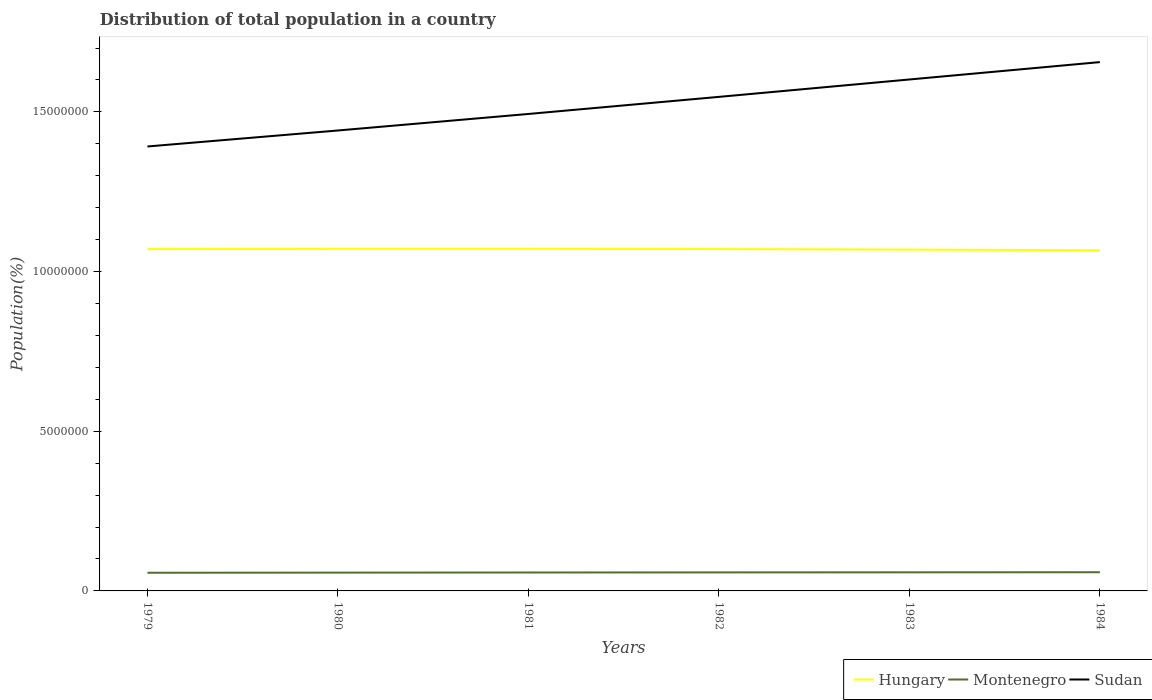Does the line corresponding to Montenegro intersect with the line corresponding to Sudan?
Offer a very short reply. No. Across all years, what is the maximum population of in Sudan?
Your response must be concise. 1.39e+07. In which year was the population of in Montenegro maximum?
Your answer should be very brief. 1979. What is the total population of in Sudan in the graph?
Offer a very short reply. -5.01e+05. What is the difference between the highest and the second highest population of in Hungary?
Your answer should be compact. 4.38e+04. Is the population of in Hungary strictly greater than the population of in Montenegro over the years?
Give a very brief answer. No. How many years are there in the graph?
Your answer should be compact. 6. What is the difference between two consecutive major ticks on the Y-axis?
Provide a short and direct response. 5.00e+06. Are the values on the major ticks of Y-axis written in scientific E-notation?
Provide a succinct answer. No. Where does the legend appear in the graph?
Offer a very short reply. Bottom right. How many legend labels are there?
Your answer should be compact. 3. What is the title of the graph?
Your response must be concise. Distribution of total population in a country. What is the label or title of the X-axis?
Your answer should be very brief. Years. What is the label or title of the Y-axis?
Give a very brief answer. Population(%). What is the Population(%) in Hungary in 1979?
Your answer should be very brief. 1.07e+07. What is the Population(%) of Montenegro in 1979?
Make the answer very short. 5.69e+05. What is the Population(%) of Sudan in 1979?
Your answer should be compact. 1.39e+07. What is the Population(%) in Hungary in 1980?
Offer a very short reply. 1.07e+07. What is the Population(%) of Montenegro in 1980?
Your answer should be compact. 5.73e+05. What is the Population(%) of Sudan in 1980?
Your response must be concise. 1.44e+07. What is the Population(%) of Hungary in 1981?
Give a very brief answer. 1.07e+07. What is the Population(%) of Montenegro in 1981?
Offer a terse response. 5.77e+05. What is the Population(%) in Sudan in 1981?
Your answer should be compact. 1.49e+07. What is the Population(%) in Hungary in 1982?
Provide a short and direct response. 1.07e+07. What is the Population(%) in Montenegro in 1982?
Ensure brevity in your answer.  5.80e+05. What is the Population(%) in Sudan in 1982?
Keep it short and to the point. 1.55e+07. What is the Population(%) of Hungary in 1983?
Make the answer very short. 1.07e+07. What is the Population(%) in Montenegro in 1983?
Give a very brief answer. 5.82e+05. What is the Population(%) of Sudan in 1983?
Provide a short and direct response. 1.60e+07. What is the Population(%) in Hungary in 1984?
Provide a succinct answer. 1.07e+07. What is the Population(%) in Montenegro in 1984?
Offer a terse response. 5.85e+05. What is the Population(%) of Sudan in 1984?
Provide a succinct answer. 1.66e+07. Across all years, what is the maximum Population(%) in Hungary?
Your response must be concise. 1.07e+07. Across all years, what is the maximum Population(%) in Montenegro?
Your answer should be compact. 5.85e+05. Across all years, what is the maximum Population(%) in Sudan?
Give a very brief answer. 1.66e+07. Across all years, what is the minimum Population(%) of Hungary?
Keep it short and to the point. 1.07e+07. Across all years, what is the minimum Population(%) in Montenegro?
Provide a short and direct response. 5.69e+05. Across all years, what is the minimum Population(%) of Sudan?
Ensure brevity in your answer.  1.39e+07. What is the total Population(%) of Hungary in the graph?
Your response must be concise. 6.42e+07. What is the total Population(%) in Montenegro in the graph?
Offer a very short reply. 3.47e+06. What is the total Population(%) of Sudan in the graph?
Give a very brief answer. 9.13e+07. What is the difference between the Population(%) in Hungary in 1979 and that in 1980?
Offer a very short reply. -6970. What is the difference between the Population(%) in Montenegro in 1979 and that in 1980?
Your answer should be compact. -4204. What is the difference between the Population(%) in Sudan in 1979 and that in 1980?
Your response must be concise. -5.01e+05. What is the difference between the Population(%) of Hungary in 1979 and that in 1981?
Your answer should be compact. -7696. What is the difference between the Population(%) in Montenegro in 1979 and that in 1981?
Ensure brevity in your answer.  -7712. What is the difference between the Population(%) of Sudan in 1979 and that in 1981?
Your response must be concise. -1.02e+06. What is the difference between the Population(%) in Hungary in 1979 and that in 1982?
Give a very brief answer. -1383. What is the difference between the Population(%) in Montenegro in 1979 and that in 1982?
Provide a succinct answer. -1.06e+04. What is the difference between the Population(%) of Sudan in 1979 and that in 1982?
Your response must be concise. -1.55e+06. What is the difference between the Population(%) of Hungary in 1979 and that in 1983?
Your answer should be very brief. 1.47e+04. What is the difference between the Population(%) in Montenegro in 1979 and that in 1983?
Ensure brevity in your answer.  -1.33e+04. What is the difference between the Population(%) in Sudan in 1979 and that in 1983?
Keep it short and to the point. -2.10e+06. What is the difference between the Population(%) of Hungary in 1979 and that in 1984?
Keep it short and to the point. 3.61e+04. What is the difference between the Population(%) of Montenegro in 1979 and that in 1984?
Provide a short and direct response. -1.61e+04. What is the difference between the Population(%) of Sudan in 1979 and that in 1984?
Keep it short and to the point. -2.64e+06. What is the difference between the Population(%) of Hungary in 1980 and that in 1981?
Offer a terse response. -726. What is the difference between the Population(%) in Montenegro in 1980 and that in 1981?
Provide a succinct answer. -3508. What is the difference between the Population(%) in Sudan in 1980 and that in 1981?
Ensure brevity in your answer.  -5.17e+05. What is the difference between the Population(%) in Hungary in 1980 and that in 1982?
Your answer should be very brief. 5587. What is the difference between the Population(%) in Montenegro in 1980 and that in 1982?
Offer a very short reply. -6411. What is the difference between the Population(%) in Sudan in 1980 and that in 1982?
Your answer should be compact. -1.05e+06. What is the difference between the Population(%) in Hungary in 1980 and that in 1983?
Your response must be concise. 2.17e+04. What is the difference between the Population(%) of Montenegro in 1980 and that in 1983?
Provide a succinct answer. -9047. What is the difference between the Population(%) in Sudan in 1980 and that in 1983?
Your answer should be very brief. -1.60e+06. What is the difference between the Population(%) in Hungary in 1980 and that in 1984?
Your answer should be compact. 4.30e+04. What is the difference between the Population(%) in Montenegro in 1980 and that in 1984?
Keep it short and to the point. -1.19e+04. What is the difference between the Population(%) of Sudan in 1980 and that in 1984?
Your response must be concise. -2.14e+06. What is the difference between the Population(%) in Hungary in 1981 and that in 1982?
Offer a very short reply. 6313. What is the difference between the Population(%) in Montenegro in 1981 and that in 1982?
Keep it short and to the point. -2903. What is the difference between the Population(%) of Sudan in 1981 and that in 1982?
Provide a succinct answer. -5.35e+05. What is the difference between the Population(%) in Hungary in 1981 and that in 1983?
Make the answer very short. 2.24e+04. What is the difference between the Population(%) of Montenegro in 1981 and that in 1983?
Provide a succinct answer. -5539. What is the difference between the Population(%) in Sudan in 1981 and that in 1983?
Make the answer very short. -1.08e+06. What is the difference between the Population(%) of Hungary in 1981 and that in 1984?
Your answer should be compact. 4.38e+04. What is the difference between the Population(%) in Montenegro in 1981 and that in 1984?
Make the answer very short. -8386. What is the difference between the Population(%) in Sudan in 1981 and that in 1984?
Make the answer very short. -1.62e+06. What is the difference between the Population(%) in Hungary in 1982 and that in 1983?
Ensure brevity in your answer.  1.61e+04. What is the difference between the Population(%) in Montenegro in 1982 and that in 1983?
Offer a very short reply. -2636. What is the difference between the Population(%) of Sudan in 1982 and that in 1983?
Your response must be concise. -5.45e+05. What is the difference between the Population(%) in Hungary in 1982 and that in 1984?
Your answer should be very brief. 3.74e+04. What is the difference between the Population(%) of Montenegro in 1982 and that in 1984?
Ensure brevity in your answer.  -5483. What is the difference between the Population(%) of Sudan in 1982 and that in 1984?
Keep it short and to the point. -1.09e+06. What is the difference between the Population(%) in Hungary in 1983 and that in 1984?
Provide a succinct answer. 2.14e+04. What is the difference between the Population(%) in Montenegro in 1983 and that in 1984?
Give a very brief answer. -2847. What is the difference between the Population(%) of Sudan in 1983 and that in 1984?
Your answer should be compact. -5.44e+05. What is the difference between the Population(%) in Hungary in 1979 and the Population(%) in Montenegro in 1980?
Provide a succinct answer. 1.01e+07. What is the difference between the Population(%) in Hungary in 1979 and the Population(%) in Sudan in 1980?
Your answer should be compact. -3.71e+06. What is the difference between the Population(%) of Montenegro in 1979 and the Population(%) of Sudan in 1980?
Offer a terse response. -1.38e+07. What is the difference between the Population(%) in Hungary in 1979 and the Population(%) in Montenegro in 1981?
Provide a short and direct response. 1.01e+07. What is the difference between the Population(%) of Hungary in 1979 and the Population(%) of Sudan in 1981?
Ensure brevity in your answer.  -4.23e+06. What is the difference between the Population(%) in Montenegro in 1979 and the Population(%) in Sudan in 1981?
Provide a short and direct response. -1.44e+07. What is the difference between the Population(%) of Hungary in 1979 and the Population(%) of Montenegro in 1982?
Offer a terse response. 1.01e+07. What is the difference between the Population(%) of Hungary in 1979 and the Population(%) of Sudan in 1982?
Give a very brief answer. -4.77e+06. What is the difference between the Population(%) of Montenegro in 1979 and the Population(%) of Sudan in 1982?
Offer a terse response. -1.49e+07. What is the difference between the Population(%) in Hungary in 1979 and the Population(%) in Montenegro in 1983?
Keep it short and to the point. 1.01e+07. What is the difference between the Population(%) in Hungary in 1979 and the Population(%) in Sudan in 1983?
Ensure brevity in your answer.  -5.31e+06. What is the difference between the Population(%) of Montenegro in 1979 and the Population(%) of Sudan in 1983?
Keep it short and to the point. -1.54e+07. What is the difference between the Population(%) in Hungary in 1979 and the Population(%) in Montenegro in 1984?
Provide a short and direct response. 1.01e+07. What is the difference between the Population(%) in Hungary in 1979 and the Population(%) in Sudan in 1984?
Your answer should be compact. -5.86e+06. What is the difference between the Population(%) of Montenegro in 1979 and the Population(%) of Sudan in 1984?
Your answer should be very brief. -1.60e+07. What is the difference between the Population(%) of Hungary in 1980 and the Population(%) of Montenegro in 1981?
Offer a terse response. 1.01e+07. What is the difference between the Population(%) of Hungary in 1980 and the Population(%) of Sudan in 1981?
Offer a terse response. -4.22e+06. What is the difference between the Population(%) in Montenegro in 1980 and the Population(%) in Sudan in 1981?
Offer a terse response. -1.44e+07. What is the difference between the Population(%) in Hungary in 1980 and the Population(%) in Montenegro in 1982?
Provide a succinct answer. 1.01e+07. What is the difference between the Population(%) of Hungary in 1980 and the Population(%) of Sudan in 1982?
Provide a succinct answer. -4.76e+06. What is the difference between the Population(%) in Montenegro in 1980 and the Population(%) in Sudan in 1982?
Provide a short and direct response. -1.49e+07. What is the difference between the Population(%) of Hungary in 1980 and the Population(%) of Montenegro in 1983?
Provide a short and direct response. 1.01e+07. What is the difference between the Population(%) of Hungary in 1980 and the Population(%) of Sudan in 1983?
Make the answer very short. -5.30e+06. What is the difference between the Population(%) of Montenegro in 1980 and the Population(%) of Sudan in 1983?
Your response must be concise. -1.54e+07. What is the difference between the Population(%) of Hungary in 1980 and the Population(%) of Montenegro in 1984?
Provide a succinct answer. 1.01e+07. What is the difference between the Population(%) of Hungary in 1980 and the Population(%) of Sudan in 1984?
Make the answer very short. -5.85e+06. What is the difference between the Population(%) in Montenegro in 1980 and the Population(%) in Sudan in 1984?
Your response must be concise. -1.60e+07. What is the difference between the Population(%) of Hungary in 1981 and the Population(%) of Montenegro in 1982?
Ensure brevity in your answer.  1.01e+07. What is the difference between the Population(%) of Hungary in 1981 and the Population(%) of Sudan in 1982?
Your response must be concise. -4.76e+06. What is the difference between the Population(%) of Montenegro in 1981 and the Population(%) of Sudan in 1982?
Give a very brief answer. -1.49e+07. What is the difference between the Population(%) of Hungary in 1981 and the Population(%) of Montenegro in 1983?
Ensure brevity in your answer.  1.01e+07. What is the difference between the Population(%) in Hungary in 1981 and the Population(%) in Sudan in 1983?
Offer a very short reply. -5.30e+06. What is the difference between the Population(%) of Montenegro in 1981 and the Population(%) of Sudan in 1983?
Ensure brevity in your answer.  -1.54e+07. What is the difference between the Population(%) in Hungary in 1981 and the Population(%) in Montenegro in 1984?
Offer a terse response. 1.01e+07. What is the difference between the Population(%) in Hungary in 1981 and the Population(%) in Sudan in 1984?
Make the answer very short. -5.85e+06. What is the difference between the Population(%) in Montenegro in 1981 and the Population(%) in Sudan in 1984?
Your response must be concise. -1.60e+07. What is the difference between the Population(%) of Hungary in 1982 and the Population(%) of Montenegro in 1983?
Give a very brief answer. 1.01e+07. What is the difference between the Population(%) of Hungary in 1982 and the Population(%) of Sudan in 1983?
Your answer should be compact. -5.31e+06. What is the difference between the Population(%) in Montenegro in 1982 and the Population(%) in Sudan in 1983?
Offer a very short reply. -1.54e+07. What is the difference between the Population(%) in Hungary in 1982 and the Population(%) in Montenegro in 1984?
Ensure brevity in your answer.  1.01e+07. What is the difference between the Population(%) of Hungary in 1982 and the Population(%) of Sudan in 1984?
Provide a succinct answer. -5.85e+06. What is the difference between the Population(%) of Montenegro in 1982 and the Population(%) of Sudan in 1984?
Offer a terse response. -1.60e+07. What is the difference between the Population(%) of Hungary in 1983 and the Population(%) of Montenegro in 1984?
Provide a short and direct response. 1.01e+07. What is the difference between the Population(%) in Hungary in 1983 and the Population(%) in Sudan in 1984?
Give a very brief answer. -5.87e+06. What is the difference between the Population(%) of Montenegro in 1983 and the Population(%) of Sudan in 1984?
Offer a very short reply. -1.60e+07. What is the average Population(%) of Hungary per year?
Your answer should be compact. 1.07e+07. What is the average Population(%) of Montenegro per year?
Your answer should be compact. 5.78e+05. What is the average Population(%) in Sudan per year?
Keep it short and to the point. 1.52e+07. In the year 1979, what is the difference between the Population(%) of Hungary and Population(%) of Montenegro?
Offer a terse response. 1.01e+07. In the year 1979, what is the difference between the Population(%) in Hungary and Population(%) in Sudan?
Give a very brief answer. -3.21e+06. In the year 1979, what is the difference between the Population(%) in Montenegro and Population(%) in Sudan?
Your answer should be very brief. -1.33e+07. In the year 1980, what is the difference between the Population(%) in Hungary and Population(%) in Montenegro?
Provide a succinct answer. 1.01e+07. In the year 1980, what is the difference between the Population(%) in Hungary and Population(%) in Sudan?
Offer a terse response. -3.71e+06. In the year 1980, what is the difference between the Population(%) in Montenegro and Population(%) in Sudan?
Provide a succinct answer. -1.38e+07. In the year 1981, what is the difference between the Population(%) in Hungary and Population(%) in Montenegro?
Your response must be concise. 1.01e+07. In the year 1981, what is the difference between the Population(%) of Hungary and Population(%) of Sudan?
Offer a terse response. -4.22e+06. In the year 1981, what is the difference between the Population(%) of Montenegro and Population(%) of Sudan?
Your answer should be compact. -1.44e+07. In the year 1982, what is the difference between the Population(%) in Hungary and Population(%) in Montenegro?
Offer a very short reply. 1.01e+07. In the year 1982, what is the difference between the Population(%) in Hungary and Population(%) in Sudan?
Provide a succinct answer. -4.76e+06. In the year 1982, what is the difference between the Population(%) in Montenegro and Population(%) in Sudan?
Make the answer very short. -1.49e+07. In the year 1983, what is the difference between the Population(%) of Hungary and Population(%) of Montenegro?
Keep it short and to the point. 1.01e+07. In the year 1983, what is the difference between the Population(%) in Hungary and Population(%) in Sudan?
Provide a short and direct response. -5.33e+06. In the year 1983, what is the difference between the Population(%) in Montenegro and Population(%) in Sudan?
Keep it short and to the point. -1.54e+07. In the year 1984, what is the difference between the Population(%) of Hungary and Population(%) of Montenegro?
Give a very brief answer. 1.01e+07. In the year 1984, what is the difference between the Population(%) of Hungary and Population(%) of Sudan?
Give a very brief answer. -5.89e+06. In the year 1984, what is the difference between the Population(%) in Montenegro and Population(%) in Sudan?
Provide a short and direct response. -1.60e+07. What is the ratio of the Population(%) in Montenegro in 1979 to that in 1980?
Offer a terse response. 0.99. What is the ratio of the Population(%) in Sudan in 1979 to that in 1980?
Your answer should be very brief. 0.97. What is the ratio of the Population(%) in Hungary in 1979 to that in 1981?
Offer a very short reply. 1. What is the ratio of the Population(%) in Montenegro in 1979 to that in 1981?
Provide a succinct answer. 0.99. What is the ratio of the Population(%) in Sudan in 1979 to that in 1981?
Your response must be concise. 0.93. What is the ratio of the Population(%) in Hungary in 1979 to that in 1982?
Offer a terse response. 1. What is the ratio of the Population(%) of Montenegro in 1979 to that in 1982?
Give a very brief answer. 0.98. What is the ratio of the Population(%) in Sudan in 1979 to that in 1982?
Provide a short and direct response. 0.9. What is the ratio of the Population(%) of Hungary in 1979 to that in 1983?
Your response must be concise. 1. What is the ratio of the Population(%) in Montenegro in 1979 to that in 1983?
Give a very brief answer. 0.98. What is the ratio of the Population(%) of Sudan in 1979 to that in 1983?
Give a very brief answer. 0.87. What is the ratio of the Population(%) in Hungary in 1979 to that in 1984?
Offer a terse response. 1. What is the ratio of the Population(%) of Montenegro in 1979 to that in 1984?
Give a very brief answer. 0.97. What is the ratio of the Population(%) in Sudan in 1979 to that in 1984?
Make the answer very short. 0.84. What is the ratio of the Population(%) of Montenegro in 1980 to that in 1981?
Offer a terse response. 0.99. What is the ratio of the Population(%) of Sudan in 1980 to that in 1981?
Provide a short and direct response. 0.97. What is the ratio of the Population(%) of Montenegro in 1980 to that in 1982?
Give a very brief answer. 0.99. What is the ratio of the Population(%) of Sudan in 1980 to that in 1982?
Offer a terse response. 0.93. What is the ratio of the Population(%) of Montenegro in 1980 to that in 1983?
Provide a succinct answer. 0.98. What is the ratio of the Population(%) in Sudan in 1980 to that in 1983?
Ensure brevity in your answer.  0.9. What is the ratio of the Population(%) in Montenegro in 1980 to that in 1984?
Your answer should be compact. 0.98. What is the ratio of the Population(%) in Sudan in 1980 to that in 1984?
Keep it short and to the point. 0.87. What is the ratio of the Population(%) of Sudan in 1981 to that in 1982?
Offer a terse response. 0.97. What is the ratio of the Population(%) of Hungary in 1981 to that in 1983?
Provide a short and direct response. 1. What is the ratio of the Population(%) in Sudan in 1981 to that in 1983?
Provide a short and direct response. 0.93. What is the ratio of the Population(%) of Hungary in 1981 to that in 1984?
Offer a very short reply. 1. What is the ratio of the Population(%) of Montenegro in 1981 to that in 1984?
Offer a terse response. 0.99. What is the ratio of the Population(%) of Sudan in 1981 to that in 1984?
Give a very brief answer. 0.9. What is the ratio of the Population(%) of Sudan in 1982 to that in 1983?
Provide a succinct answer. 0.97. What is the ratio of the Population(%) in Montenegro in 1982 to that in 1984?
Make the answer very short. 0.99. What is the ratio of the Population(%) in Sudan in 1982 to that in 1984?
Offer a very short reply. 0.93. What is the ratio of the Population(%) in Hungary in 1983 to that in 1984?
Give a very brief answer. 1. What is the ratio of the Population(%) of Montenegro in 1983 to that in 1984?
Provide a short and direct response. 1. What is the ratio of the Population(%) of Sudan in 1983 to that in 1984?
Your answer should be compact. 0.97. What is the difference between the highest and the second highest Population(%) of Hungary?
Ensure brevity in your answer.  726. What is the difference between the highest and the second highest Population(%) of Montenegro?
Offer a very short reply. 2847. What is the difference between the highest and the second highest Population(%) in Sudan?
Your answer should be compact. 5.44e+05. What is the difference between the highest and the lowest Population(%) of Hungary?
Offer a very short reply. 4.38e+04. What is the difference between the highest and the lowest Population(%) of Montenegro?
Provide a succinct answer. 1.61e+04. What is the difference between the highest and the lowest Population(%) of Sudan?
Give a very brief answer. 2.64e+06. 